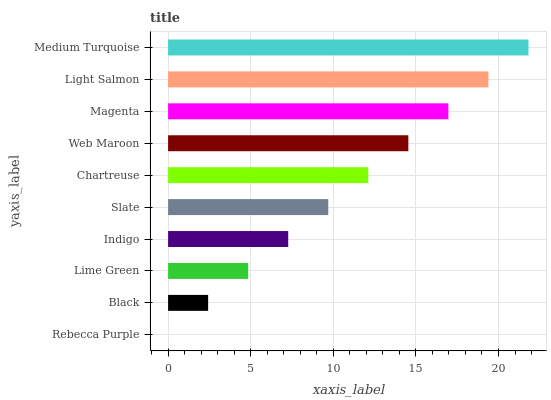Is Rebecca Purple the minimum?
Answer yes or no. Yes. Is Medium Turquoise the maximum?
Answer yes or no. Yes. Is Black the minimum?
Answer yes or no. No. Is Black the maximum?
Answer yes or no. No. Is Black greater than Rebecca Purple?
Answer yes or no. Yes. Is Rebecca Purple less than Black?
Answer yes or no. Yes. Is Rebecca Purple greater than Black?
Answer yes or no. No. Is Black less than Rebecca Purple?
Answer yes or no. No. Is Chartreuse the high median?
Answer yes or no. Yes. Is Slate the low median?
Answer yes or no. Yes. Is Medium Turquoise the high median?
Answer yes or no. No. Is Magenta the low median?
Answer yes or no. No. 